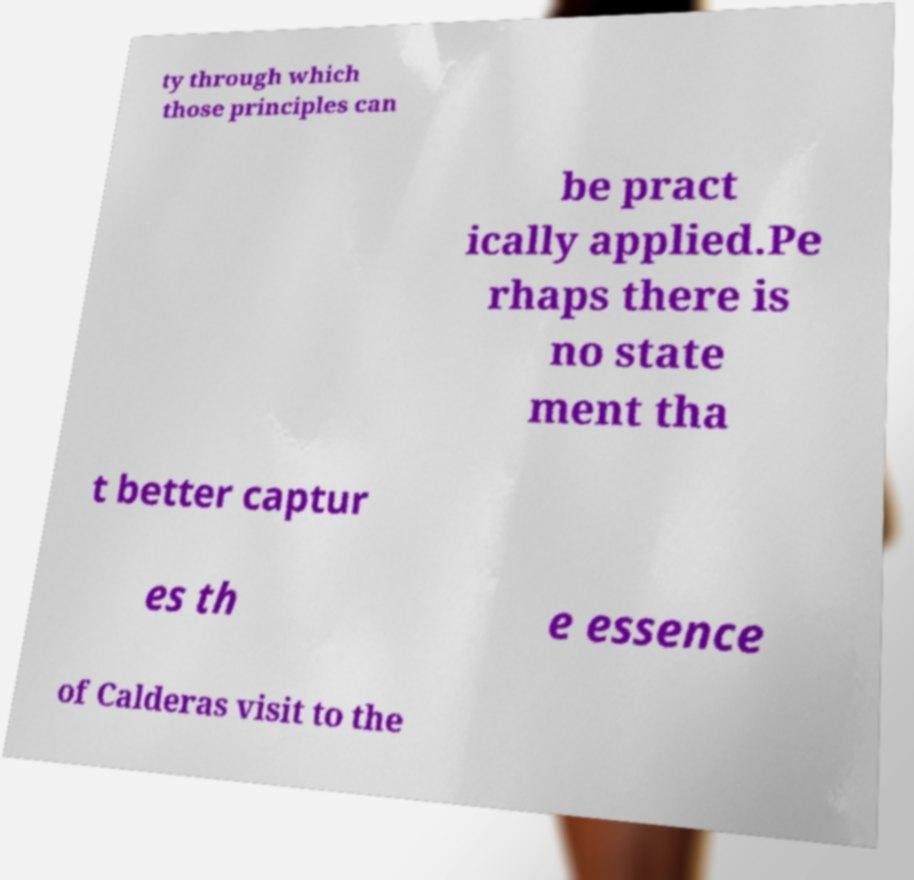I need the written content from this picture converted into text. Can you do that? ty through which those principles can be pract ically applied.Pe rhaps there is no state ment tha t better captur es th e essence of Calderas visit to the 